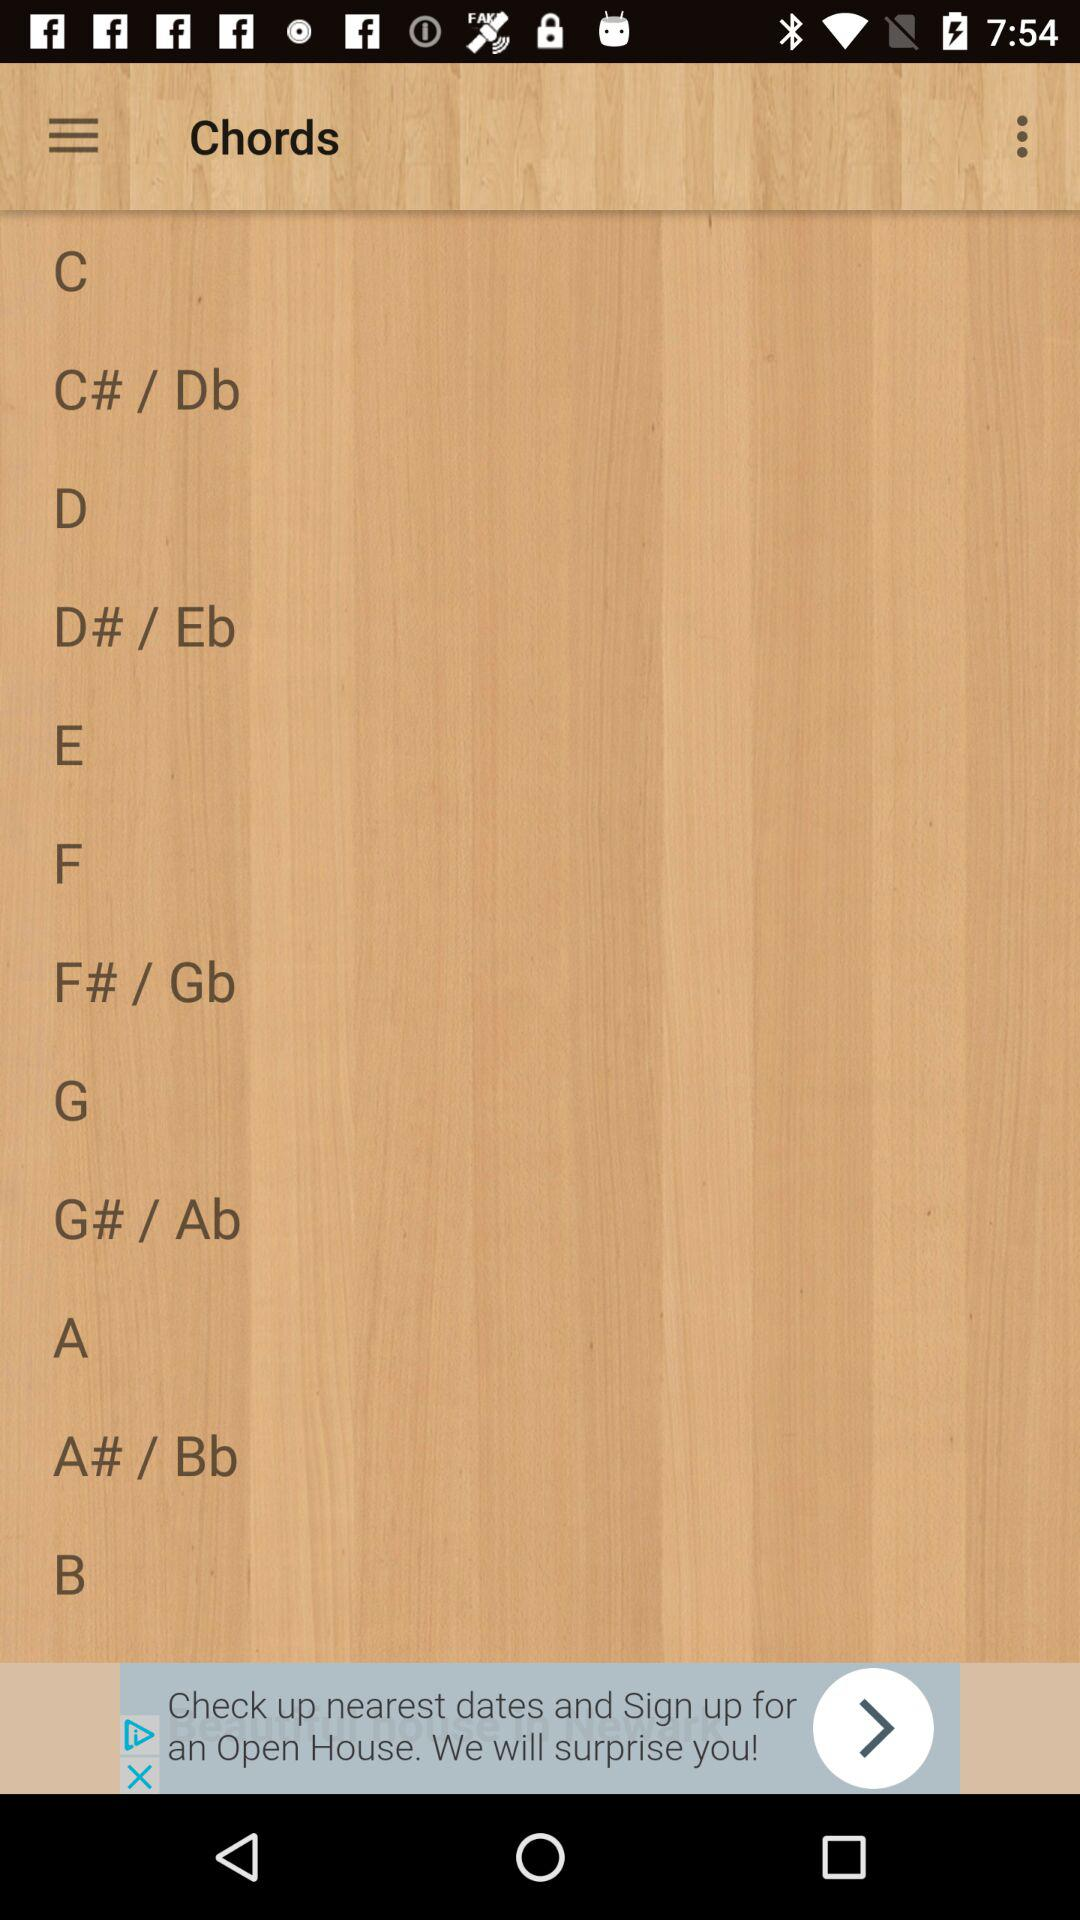How many chords are displayed on the screen?
Answer the question using a single word or phrase. 12 